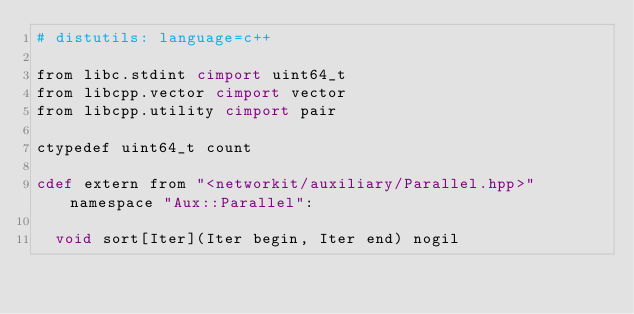Convert code to text. <code><loc_0><loc_0><loc_500><loc_500><_Cython_># distutils: language=c++

from libc.stdint cimport uint64_t
from libcpp.vector cimport vector
from libcpp.utility cimport pair

ctypedef uint64_t count

cdef extern from "<networkit/auxiliary/Parallel.hpp>" namespace "Aux::Parallel":

	void sort[Iter](Iter begin, Iter end) nogil</code> 